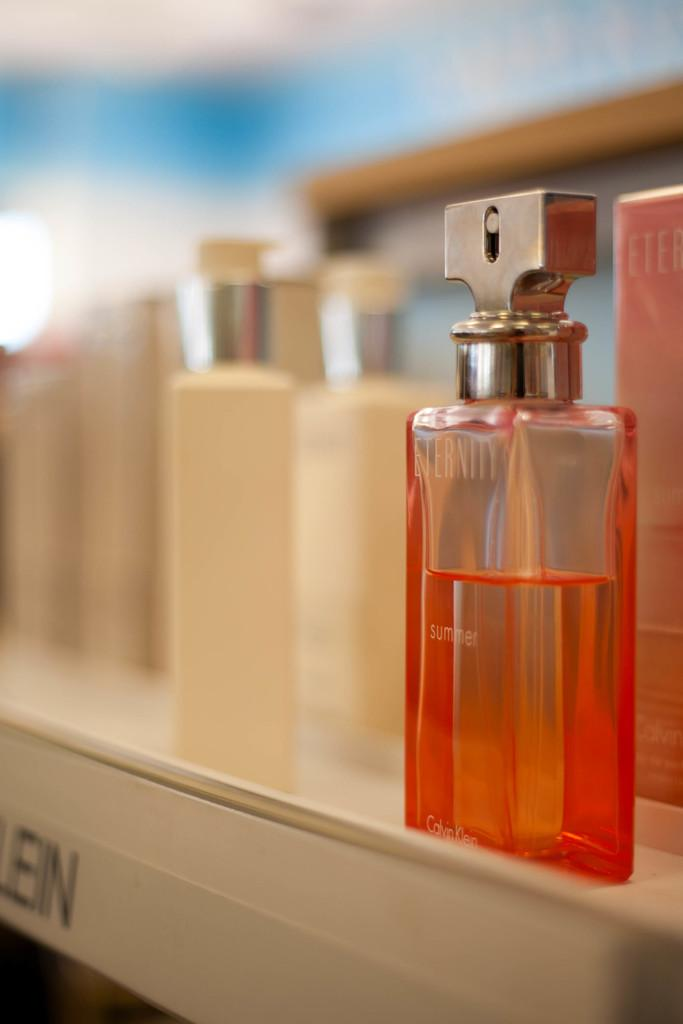<image>
Create a compact narrative representing the image presented. A bottle of orange summer perfume sits on a shelf. 